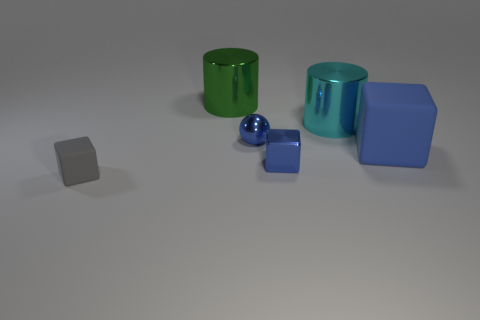What is the large blue object made of?
Offer a very short reply. Rubber. There is a matte thing to the right of the tiny rubber object; what size is it?
Make the answer very short. Large. What number of other large objects have the same shape as the large green shiny thing?
Keep it short and to the point. 1. There is a tiny object that is made of the same material as the tiny blue cube; what shape is it?
Your answer should be compact. Sphere. What number of blue things are either small matte cubes or small metal objects?
Provide a succinct answer. 2. There is a gray cube; are there any things in front of it?
Your response must be concise. No. Does the tiny thing that is on the left side of the sphere have the same shape as the large object that is to the left of the tiny metallic cube?
Provide a short and direct response. No. What is the material of the small blue thing that is the same shape as the gray thing?
Your answer should be compact. Metal. What number of cylinders are either large blue matte objects or tiny gray rubber things?
Your answer should be compact. 0. How many purple spheres are made of the same material as the large cyan cylinder?
Keep it short and to the point. 0. 